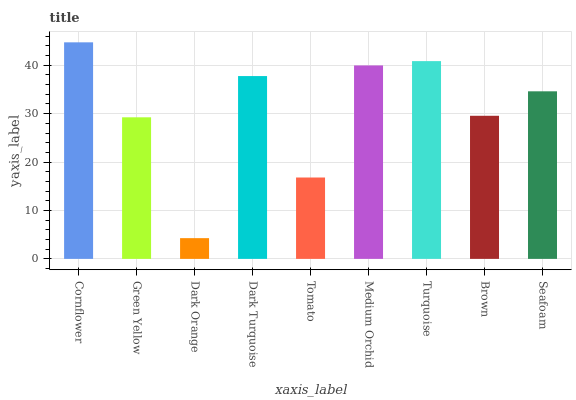Is Dark Orange the minimum?
Answer yes or no. Yes. Is Cornflower the maximum?
Answer yes or no. Yes. Is Green Yellow the minimum?
Answer yes or no. No. Is Green Yellow the maximum?
Answer yes or no. No. Is Cornflower greater than Green Yellow?
Answer yes or no. Yes. Is Green Yellow less than Cornflower?
Answer yes or no. Yes. Is Green Yellow greater than Cornflower?
Answer yes or no. No. Is Cornflower less than Green Yellow?
Answer yes or no. No. Is Seafoam the high median?
Answer yes or no. Yes. Is Seafoam the low median?
Answer yes or no. Yes. Is Medium Orchid the high median?
Answer yes or no. No. Is Brown the low median?
Answer yes or no. No. 